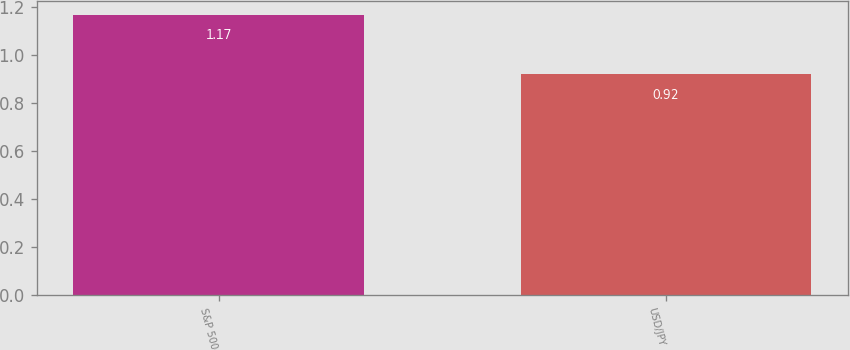Convert chart to OTSL. <chart><loc_0><loc_0><loc_500><loc_500><bar_chart><fcel>S&P 500<fcel>USD/JPY<nl><fcel>1.17<fcel>0.92<nl></chart> 